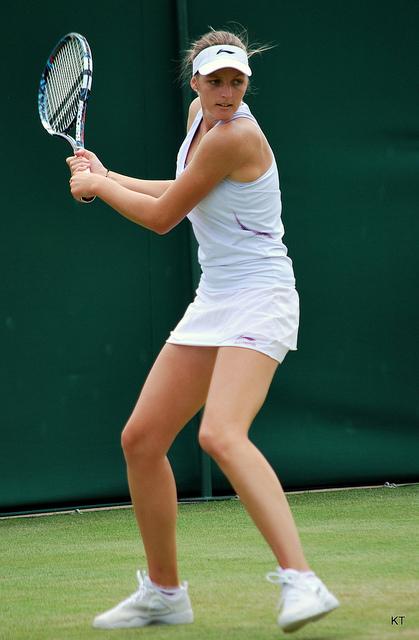What on her leg?
Answer briefly. Nothing. How hard is the woman trying?
Write a very short answer. Very. Is the woman young?
Write a very short answer. Yes. What type of shoes is the woman wearing?
Be succinct. Tennis shoes. 